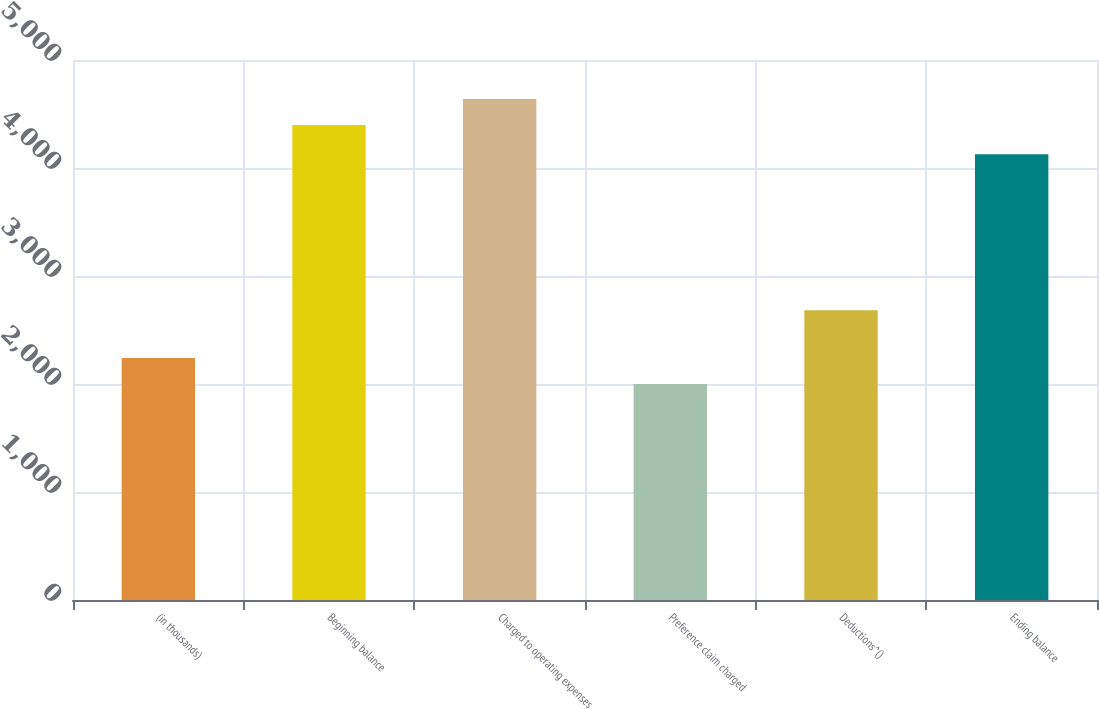<chart> <loc_0><loc_0><loc_500><loc_500><bar_chart><fcel>(in thousands)<fcel>Beginning balance<fcel>Charged to operating expenses<fcel>Preference claim charged<fcel>Deductions^()<fcel>Ending balance<nl><fcel>2241.4<fcel>4398<fcel>4639.4<fcel>2000<fcel>2684<fcel>4128<nl></chart> 